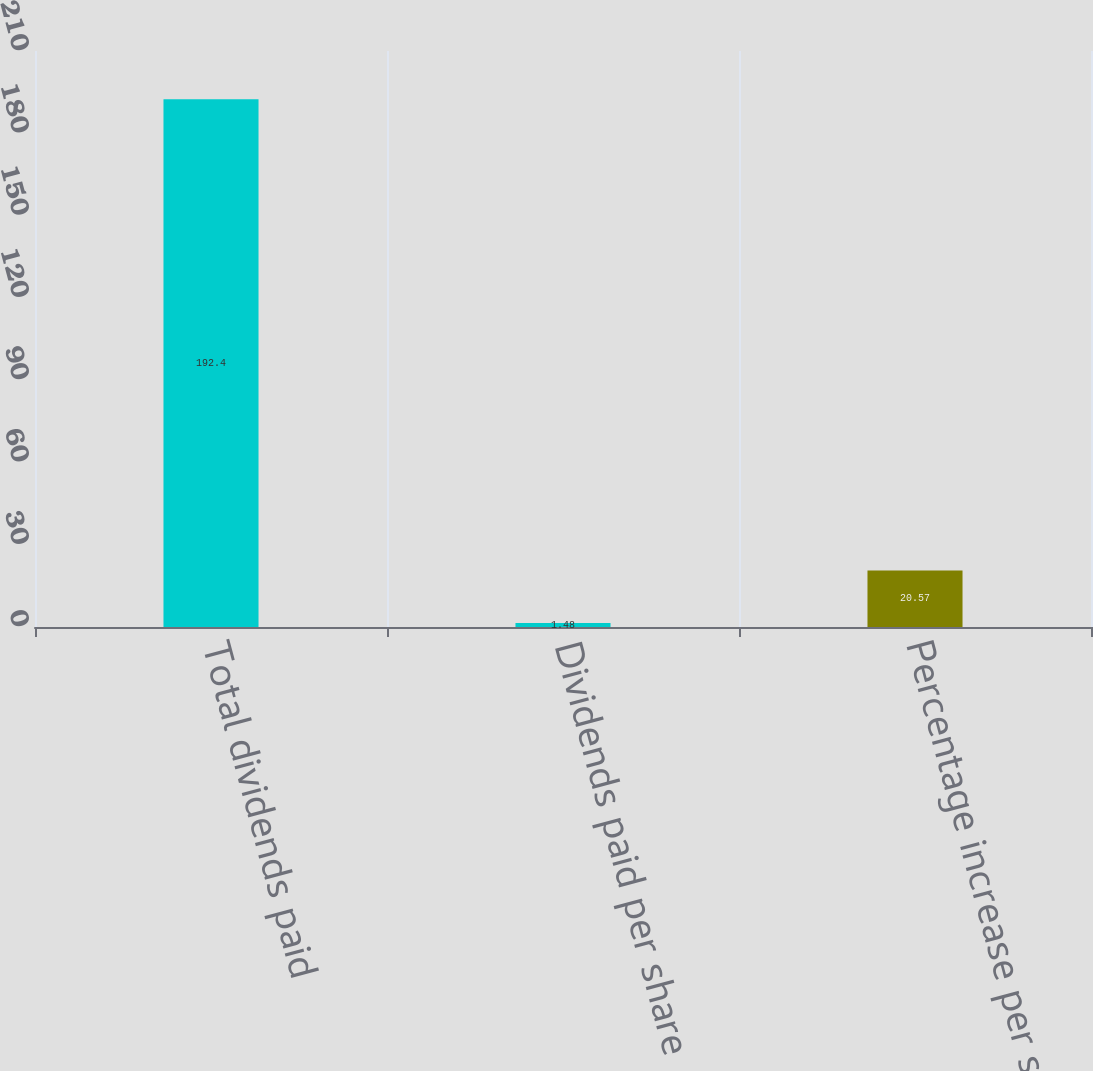Convert chart to OTSL. <chart><loc_0><loc_0><loc_500><loc_500><bar_chart><fcel>Total dividends paid<fcel>Dividends paid per share<fcel>Percentage increase per share<nl><fcel>192.4<fcel>1.48<fcel>20.57<nl></chart> 